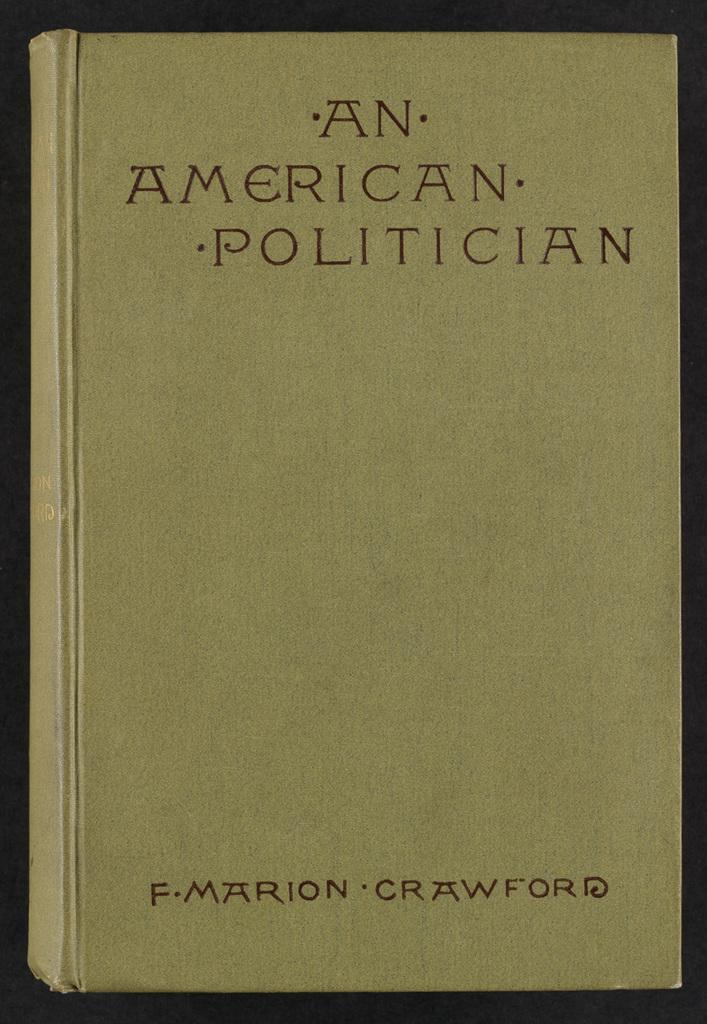Provide a one-sentence caption for the provided image. A yellow book cover titled An American Politician. 